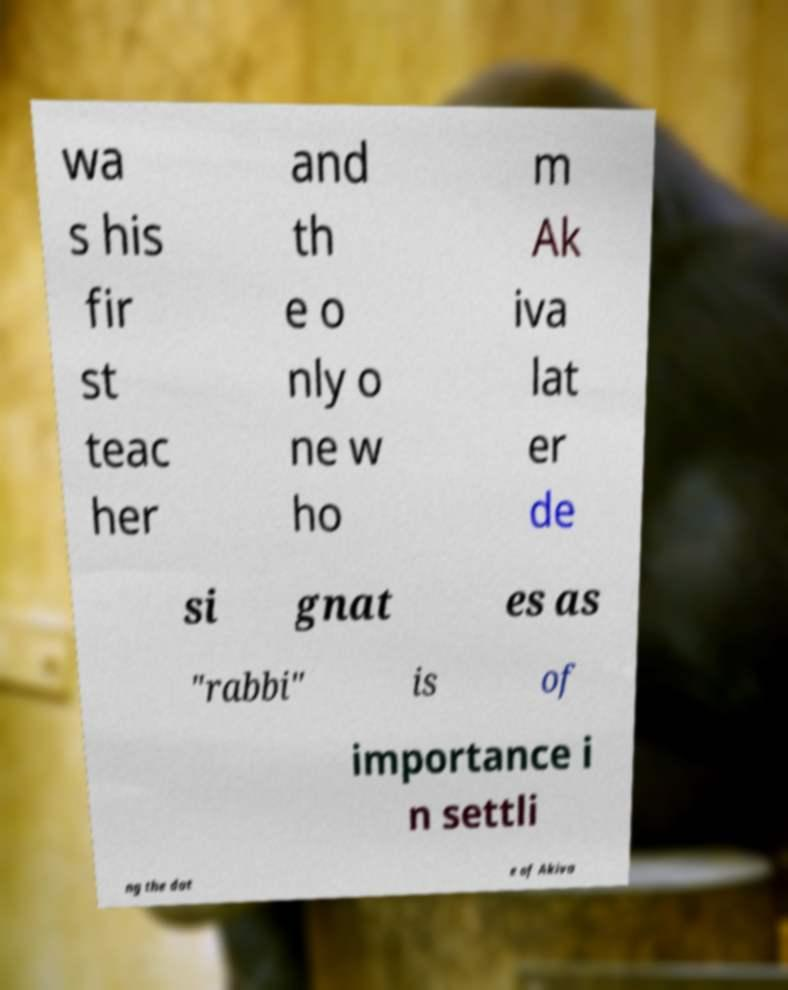Please read and relay the text visible in this image. What does it say? wa s his fir st teac her and th e o nly o ne w ho m Ak iva lat er de si gnat es as "rabbi" is of importance i n settli ng the dat e of Akiva 